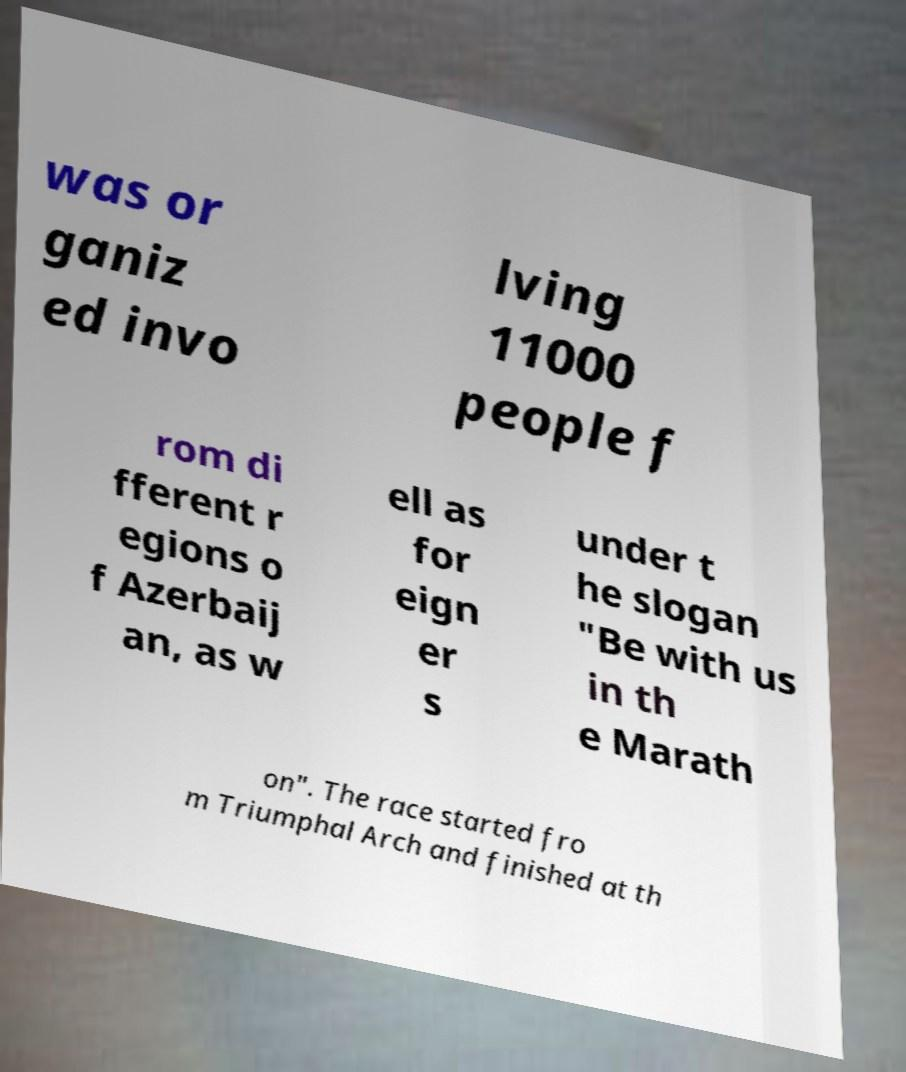Could you assist in decoding the text presented in this image and type it out clearly? was or ganiz ed invo lving 11000 people f rom di fferent r egions o f Azerbaij an, as w ell as for eign er s under t he slogan "Be with us in th e Marath on". The race started fro m Triumphal Arch and finished at th 